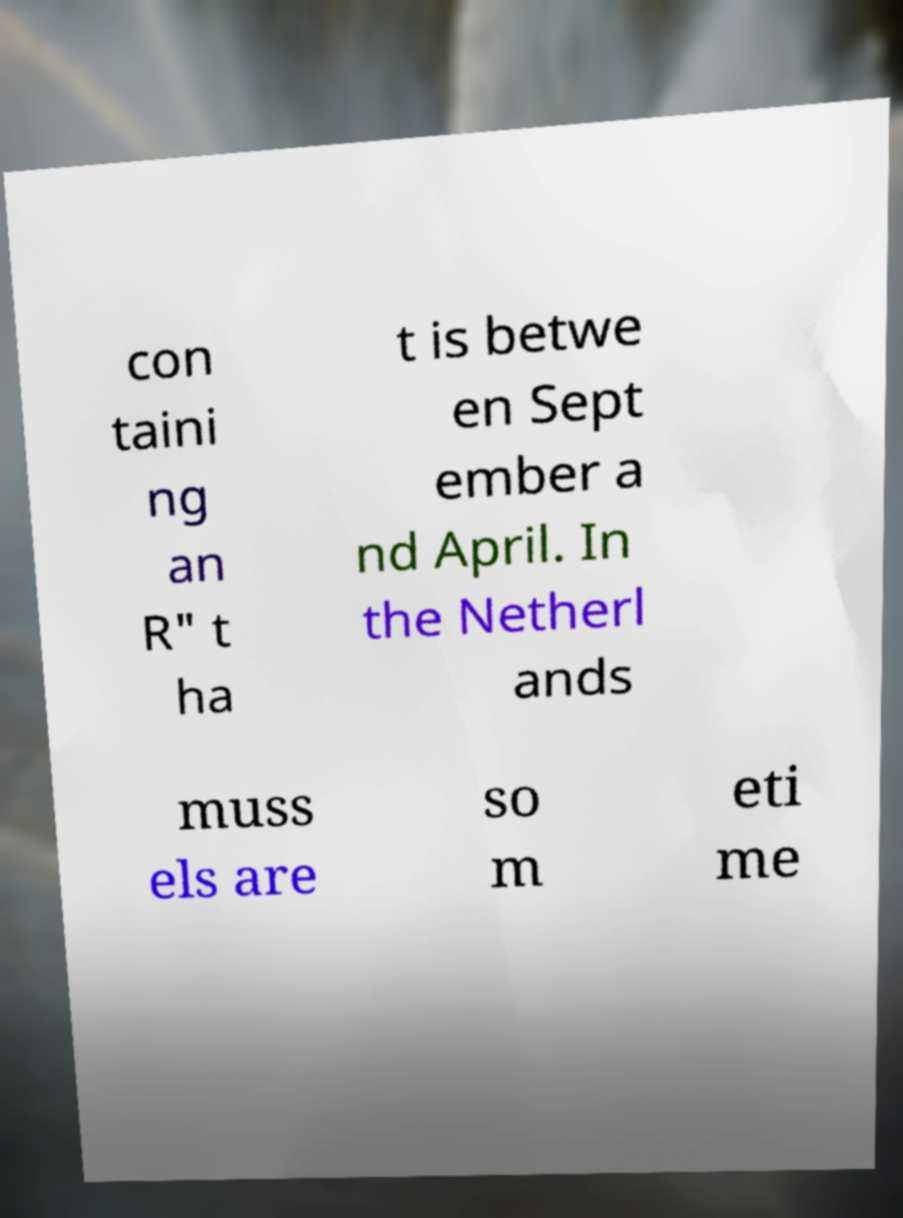Can you accurately transcribe the text from the provided image for me? con taini ng an R" t ha t is betwe en Sept ember a nd April. In the Netherl ands muss els are so m eti me 